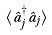<formula> <loc_0><loc_0><loc_500><loc_500>\langle \hat { a } _ { j } ^ { \dagger } \hat { a } _ { j } \rangle</formula> 